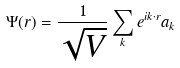<formula> <loc_0><loc_0><loc_500><loc_500>\Psi ( r ) = { \frac { 1 } { \sqrt { V } } } \sum _ { k } e ^ { i k \cdot r } a _ { k }</formula> 